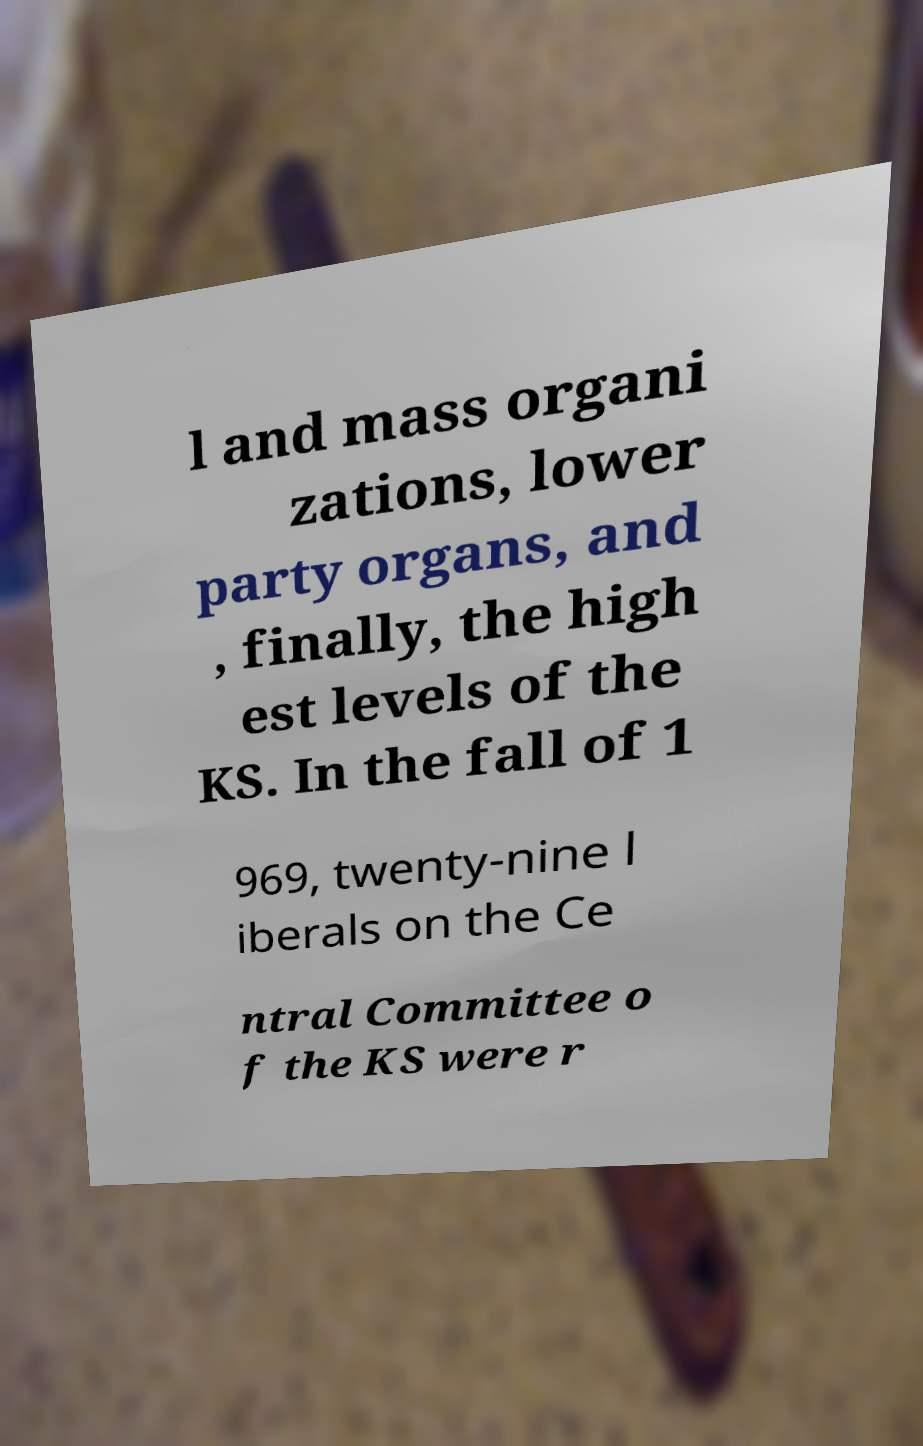For documentation purposes, I need the text within this image transcribed. Could you provide that? l and mass organi zations, lower party organs, and , finally, the high est levels of the KS. In the fall of 1 969, twenty-nine l iberals on the Ce ntral Committee o f the KS were r 